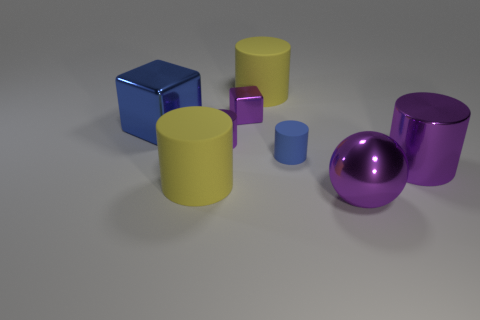Subtract all purple cylinders. How many were subtracted if there are1purple cylinders left? 1 Subtract 1 cylinders. How many cylinders are left? 4 Subtract all big purple metallic cylinders. How many cylinders are left? 4 Subtract all blue cylinders. How many cylinders are left? 4 Subtract all gray cylinders. Subtract all red balls. How many cylinders are left? 5 Add 2 purple shiny things. How many objects exist? 10 Subtract all spheres. How many objects are left? 7 Add 7 big metallic spheres. How many big metallic spheres are left? 8 Add 2 small yellow matte blocks. How many small yellow matte blocks exist? 2 Subtract 0 brown cylinders. How many objects are left? 8 